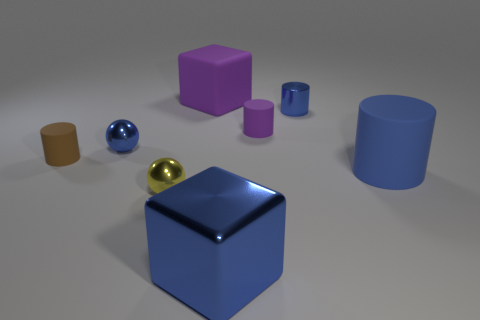Subtract all small blue shiny cylinders. How many cylinders are left? 3 Add 1 small cylinders. How many objects exist? 9 Subtract all purple balls. How many blue cylinders are left? 2 Subtract all brown cylinders. How many cylinders are left? 3 Subtract all cubes. How many objects are left? 6 Add 4 purple blocks. How many purple blocks are left? 5 Add 8 cubes. How many cubes exist? 10 Subtract 0 cyan spheres. How many objects are left? 8 Subtract all red cylinders. Subtract all purple balls. How many cylinders are left? 4 Subtract all green shiny cylinders. Subtract all blue cylinders. How many objects are left? 6 